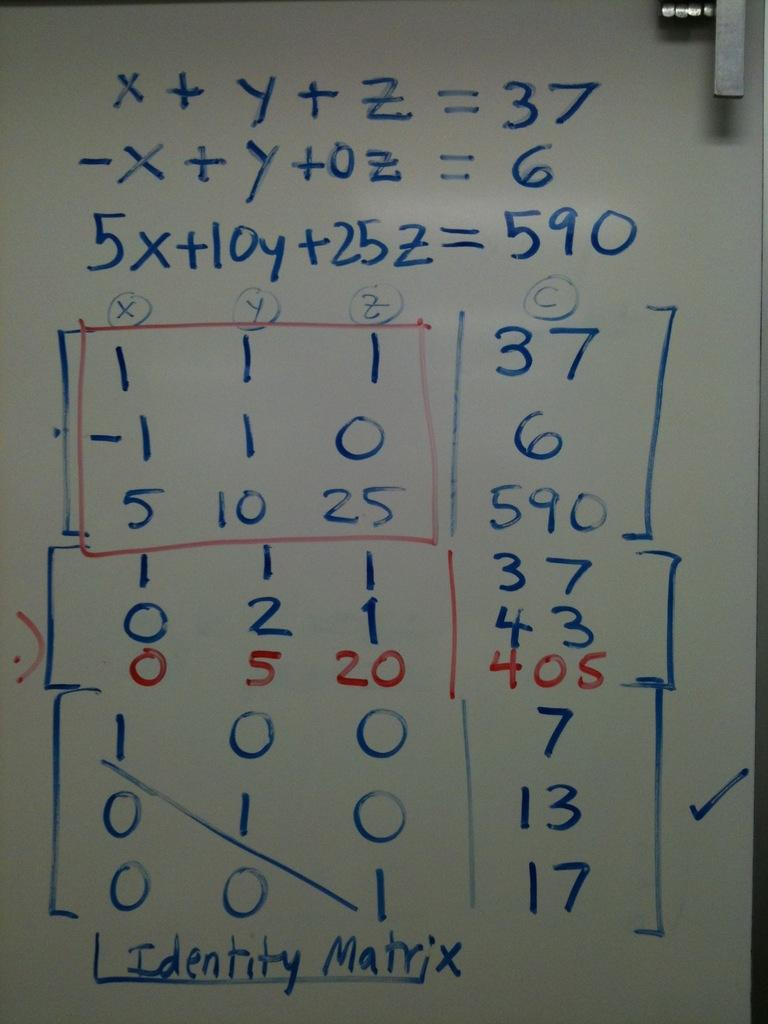What is present on the paper in the image? The paper contains numbers and text. Can you describe the object located in the top right side of the image? Unfortunately, the provided facts do not give enough information to describe the object in the top right side of the image. What type of bread can be seen in the image? There is no bread present in the image. Can you describe the bird that is flying in the image? There is no bird present in the image. 